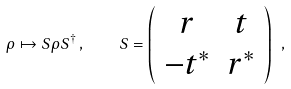<formula> <loc_0><loc_0><loc_500><loc_500>\rho \mapsto S \rho S ^ { \dagger } \, , \quad S = \left ( \begin{array} { c c } r & t \\ - t ^ { * } & r ^ { * } \end{array} \right ) \ ,</formula> 